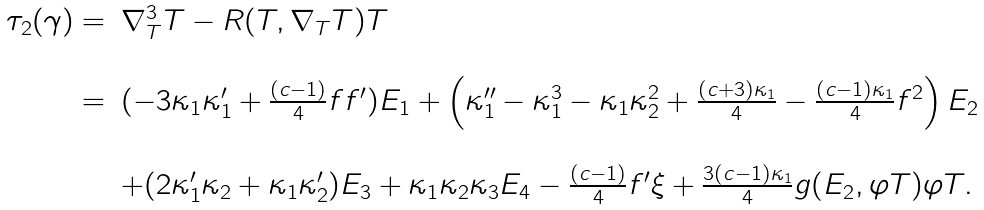<formula> <loc_0><loc_0><loc_500><loc_500>\begin{array} { r l } \tau _ { 2 } ( \gamma ) = & \nabla _ { T } ^ { 3 } T - R ( T , \nabla _ { T } T ) T \\ \\ = & ( - 3 \kappa _ { 1 } \kappa _ { 1 } ^ { \prime } + \frac { ( c - 1 ) } { 4 } f f ^ { \prime } ) E _ { 1 } + \left ( \kappa _ { 1 } ^ { \prime \prime } - \kappa _ { 1 } ^ { 3 } - \kappa _ { 1 } \kappa _ { 2 } ^ { 2 } + \frac { ( c + 3 ) \kappa _ { 1 } } { 4 } - \frac { ( c - 1 ) \kappa _ { 1 } } { 4 } f ^ { 2 } \right ) E _ { 2 } \\ \\ & + ( 2 \kappa _ { 1 } ^ { \prime } \kappa _ { 2 } + \kappa _ { 1 } \kappa _ { 2 } ^ { \prime } ) E _ { 3 } + \kappa _ { 1 } \kappa _ { 2 } \kappa _ { 3 } E _ { 4 } - \frac { ( c - 1 ) } { 4 } f ^ { \prime } \xi + \frac { 3 ( c - 1 ) \kappa _ { 1 } } { 4 } g ( E _ { 2 } , \varphi T ) \varphi T . \end{array}</formula> 